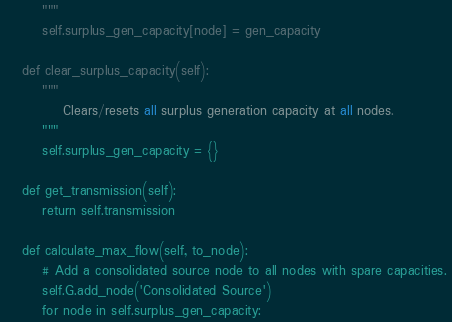<code> <loc_0><loc_0><loc_500><loc_500><_Python_>        """
        self.surplus_gen_capacity[node] = gen_capacity
    
    def clear_surplus_capacity(self):
        """
            Clears/resets all surplus generation capacity at all nodes. 
        """
        self.surplus_gen_capacity = {}

    def get_transmission(self):
        return self.transmission

    def calculate_max_flow(self, to_node):
        # Add a consolidated source node to all nodes with spare capacities. 
        self.G.add_node('Consolidated Source')
        for node in self.surplus_gen_capacity:</code> 